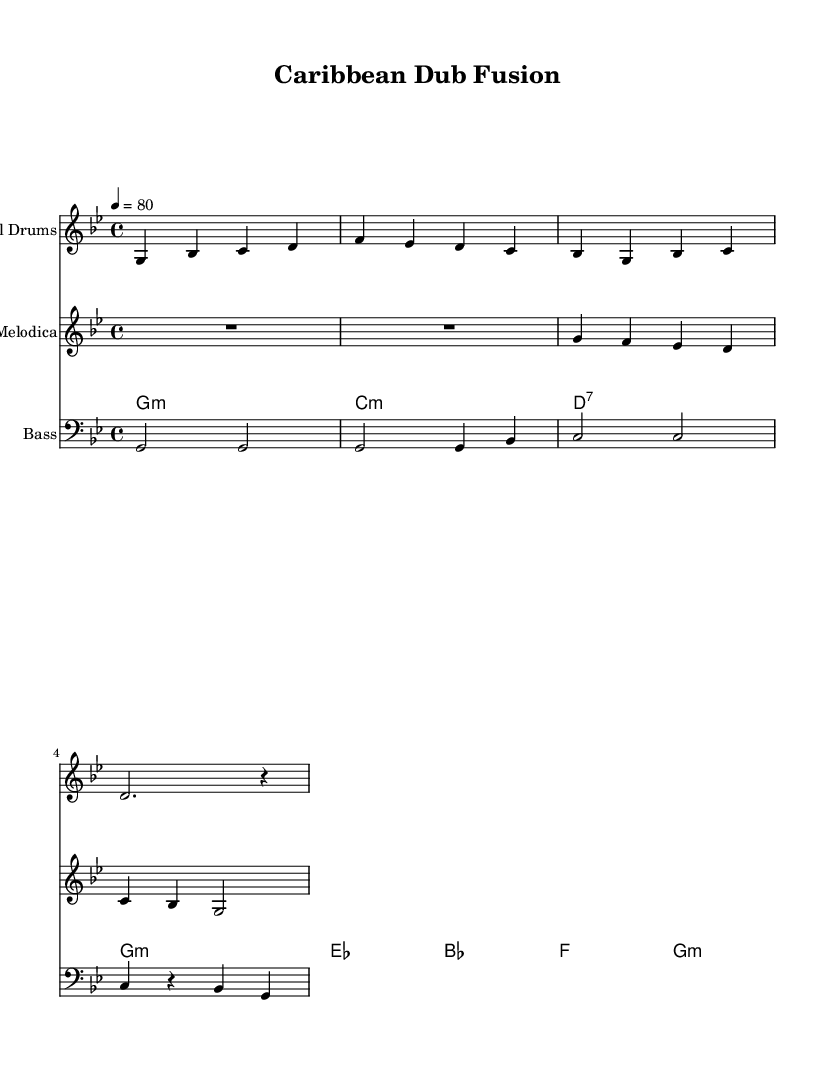What is the key signature of this music? The key signature is G minor, indicated by the presence of B flat and E flat.
Answer: G minor What is the time signature of the piece? The time signature is 4/4, shown at the beginning of the score.
Answer: 4/4 What is the tempo marking for the piece? The tempo is marked as quarter note equals 80, indicating a moderate pace for the music.
Answer: 80 Which instrument plays the melody in the first system? The steel drums play the melody in the first system, as the staff is labeled with that instrument's name.
Answer: Steel Drums How many measures are there in the steel drums part? The steel drums part has four measures, counting the bars across the notation.
Answer: 4 What type of chord is used on the first measure of the electric guitar? The first measure of the electric guitar uses a minor chord, specifically G minor as indicated by the notation.
Answer: G minor Which rhythmic pattern is commonly used in reggae music, as seen in the bass guitar part? The bass guitar part often uses a pattern of syncopation, emphasizing off beats commonly found in reggae music.
Answer: Syncopation 